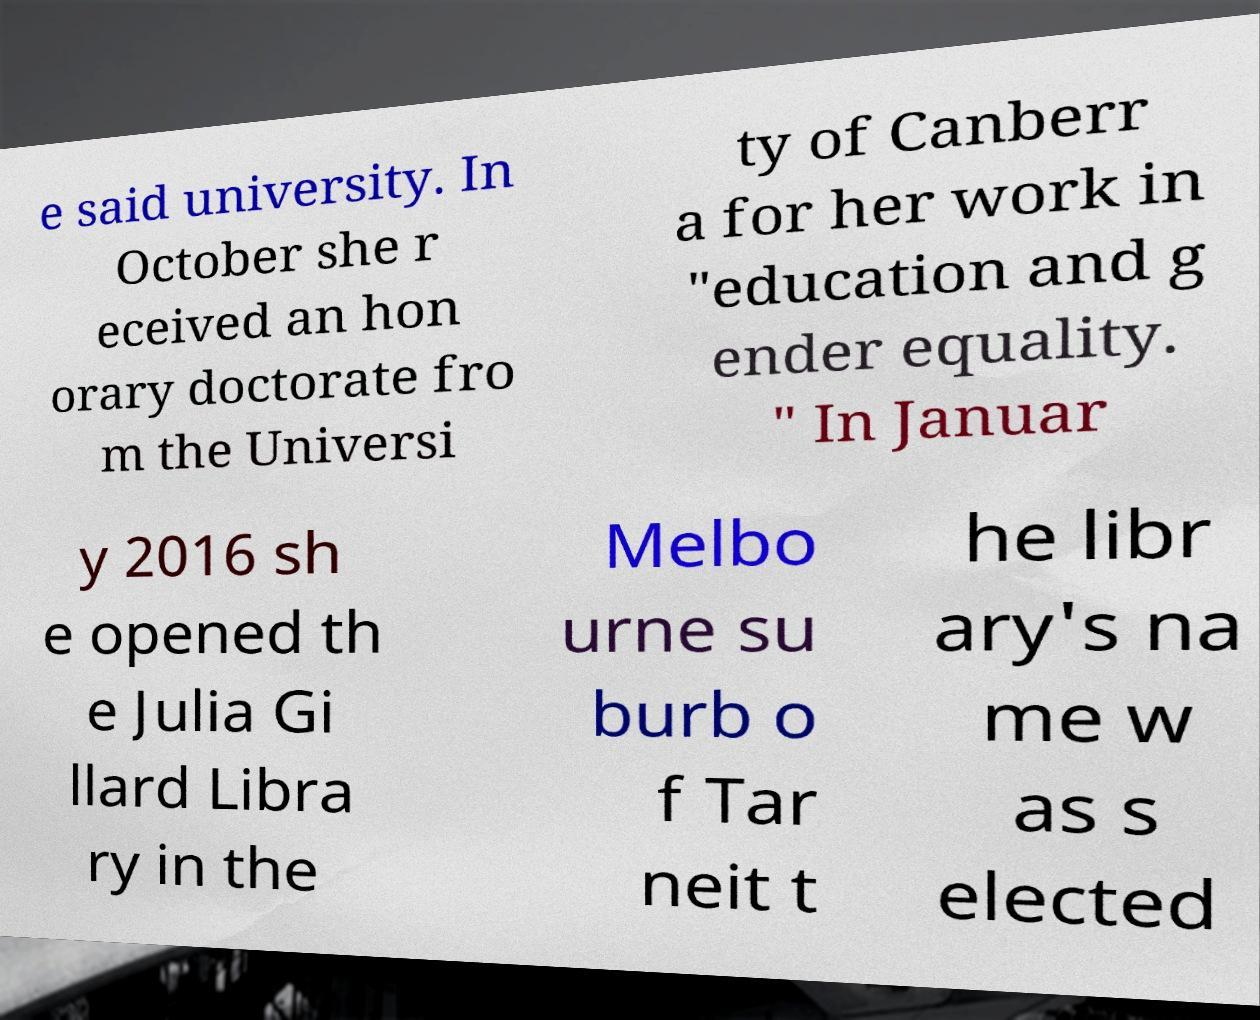Can you read and provide the text displayed in the image?This photo seems to have some interesting text. Can you extract and type it out for me? e said university. In October she r eceived an hon orary doctorate fro m the Universi ty of Canberr a for her work in "education and g ender equality. " In Januar y 2016 sh e opened th e Julia Gi llard Libra ry in the Melbo urne su burb o f Tar neit t he libr ary's na me w as s elected 